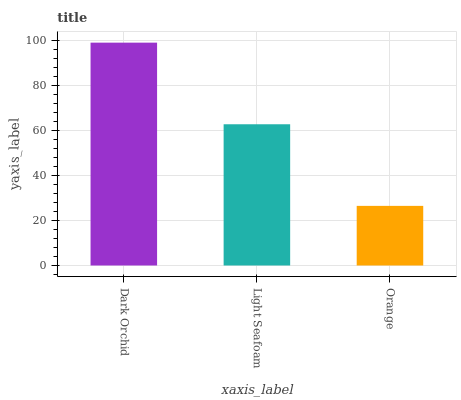Is Orange the minimum?
Answer yes or no. Yes. Is Dark Orchid the maximum?
Answer yes or no. Yes. Is Light Seafoam the minimum?
Answer yes or no. No. Is Light Seafoam the maximum?
Answer yes or no. No. Is Dark Orchid greater than Light Seafoam?
Answer yes or no. Yes. Is Light Seafoam less than Dark Orchid?
Answer yes or no. Yes. Is Light Seafoam greater than Dark Orchid?
Answer yes or no. No. Is Dark Orchid less than Light Seafoam?
Answer yes or no. No. Is Light Seafoam the high median?
Answer yes or no. Yes. Is Light Seafoam the low median?
Answer yes or no. Yes. Is Dark Orchid the high median?
Answer yes or no. No. Is Orange the low median?
Answer yes or no. No. 